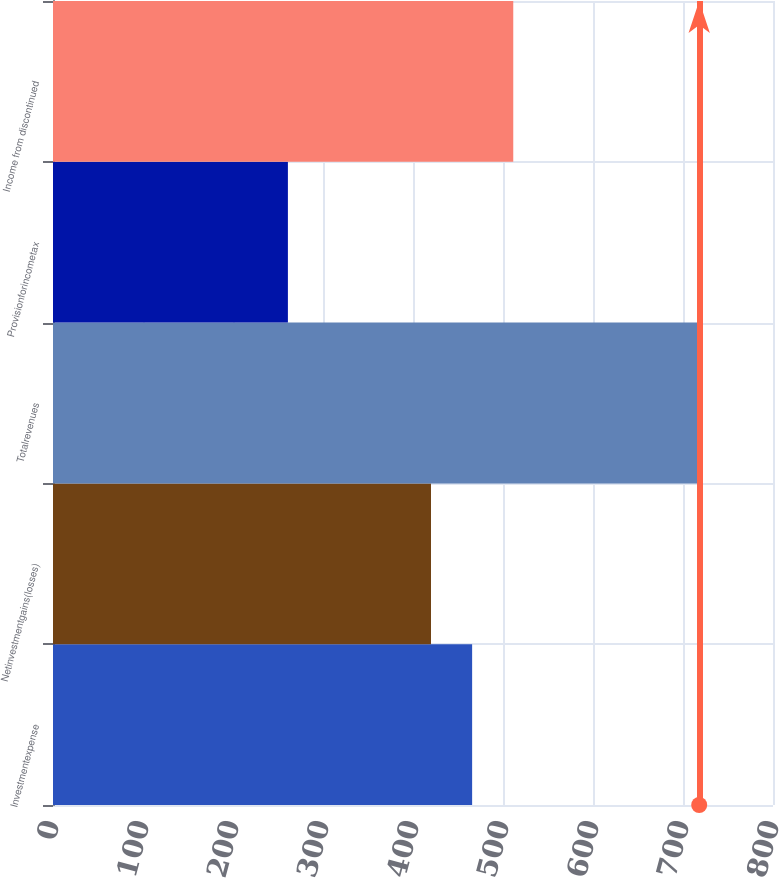Convert chart. <chart><loc_0><loc_0><loc_500><loc_500><bar_chart><fcel>Investmentexpense<fcel>Netinvestmentgains(losses)<fcel>Totalrevenues<fcel>Provisionforincometax<fcel>Income from discontinued<nl><fcel>465.7<fcel>420<fcel>718<fcel>261<fcel>511.4<nl></chart> 